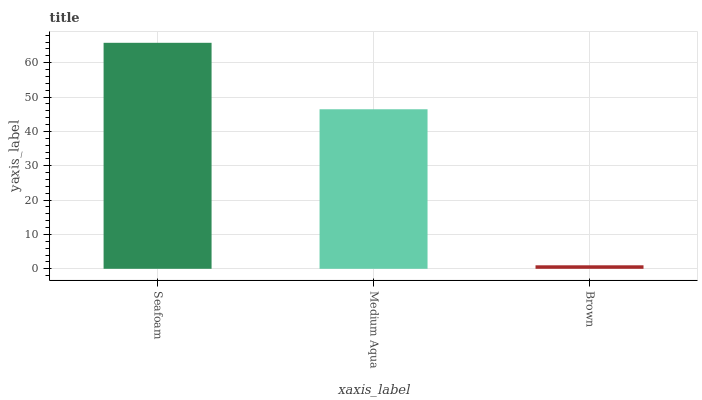Is Medium Aqua the minimum?
Answer yes or no. No. Is Medium Aqua the maximum?
Answer yes or no. No. Is Seafoam greater than Medium Aqua?
Answer yes or no. Yes. Is Medium Aqua less than Seafoam?
Answer yes or no. Yes. Is Medium Aqua greater than Seafoam?
Answer yes or no. No. Is Seafoam less than Medium Aqua?
Answer yes or no. No. Is Medium Aqua the high median?
Answer yes or no. Yes. Is Medium Aqua the low median?
Answer yes or no. Yes. Is Brown the high median?
Answer yes or no. No. Is Brown the low median?
Answer yes or no. No. 